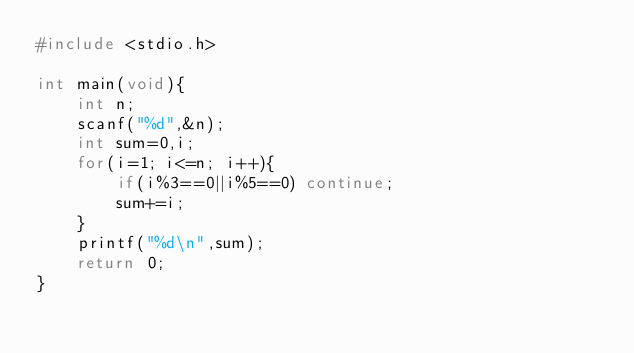Convert code to text. <code><loc_0><loc_0><loc_500><loc_500><_C_>#include <stdio.h>

int main(void){
    int n;
    scanf("%d",&n);
    int sum=0,i;
    for(i=1; i<=n; i++){
        if(i%3==0||i%5==0) continue;
        sum+=i;
    }
    printf("%d\n",sum);
    return 0;
}</code> 